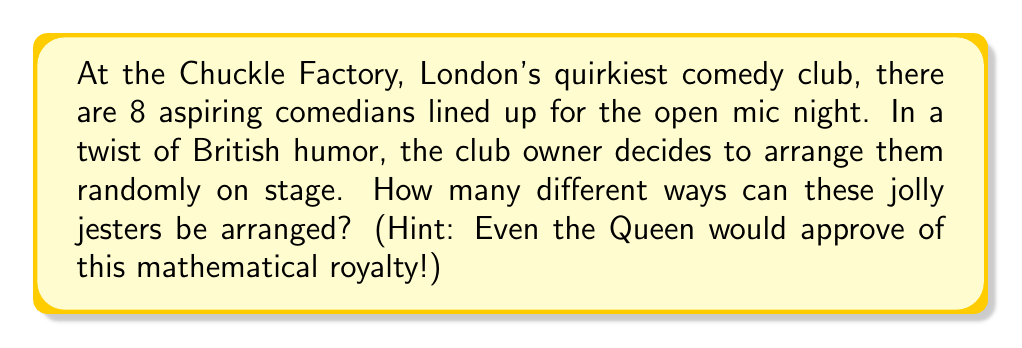Can you answer this question? Let's approach this with a stiff upper lip and a dash of British wit!

1) First, we need to recognize that this is a permutation problem. We're arranging all 8 comedians, and the order matters (as timing is everything in comedy!).

2) The formula for permutations of n distinct objects is:

   $$P(n) = n!$$

   Where $n!$ (n factorial) is the product of all positive integers less than or equal to n.

3) In this case, $n = 8$ (the number of comedians).

4) So, we calculate:

   $$8! = 8 \times 7 \times 6 \times 5 \times 4 \times 3 \times 2 \times 1$$

5) Let's break this down step by step:
   
   $8 \times 7 = 56$
   $56 \times 6 = 336$
   $336 \times 5 = 1,680$
   $1,680 \times 4 = 6,720$
   $6,720 \times 3 = 20,160$
   $20,160 \times 2 = 40,320$
   $40,320 \times 1 = 40,320$

6) Therefore, the number of possible arrangements is 40,320.

Blimey! That's more arrangements than there are tea bags in the average British cupboard!
Answer: $40,320$ different arrangements 